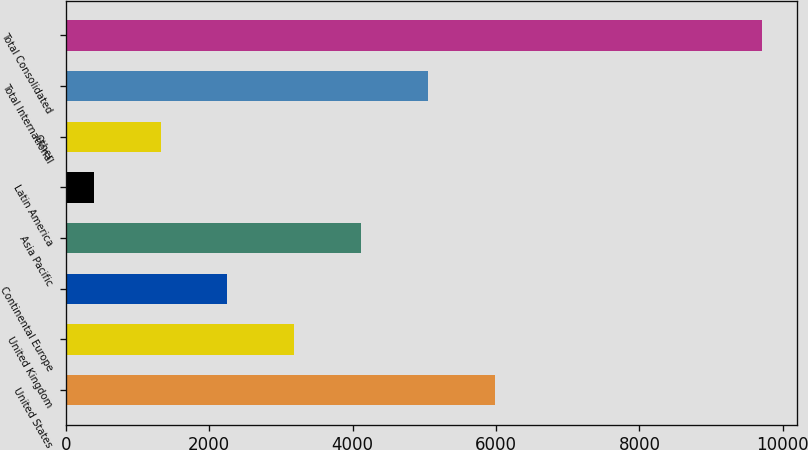Convert chart. <chart><loc_0><loc_0><loc_500><loc_500><bar_chart><fcel>United States<fcel>United Kingdom<fcel>Continental Europe<fcel>Asia Pacific<fcel>Latin America<fcel>Other<fcel>Total International<fcel>Total Consolidated<nl><fcel>5984.24<fcel>3186.62<fcel>2254.08<fcel>4119.16<fcel>389<fcel>1321.54<fcel>5051.7<fcel>9714.4<nl></chart> 